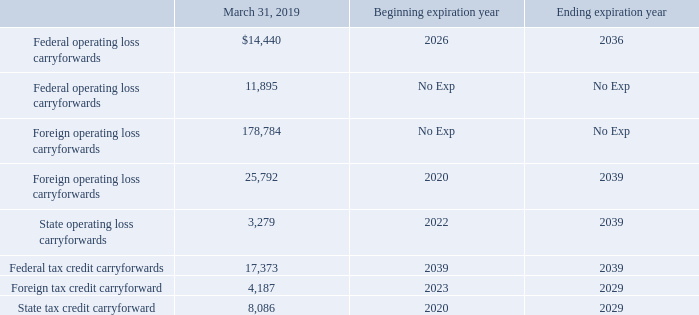The following table presents the approximate amount of federal, foreign and state operating loss carryforwards and federal tax credit carryforwards available to
reduce future taxable income, along with the respective range of years that the operating loss and tax credit carryforwards would expired if not utilized:
At March 31, 2019, certain of our U.S. and foreign subsidiaries in Brazil, France, Germany, Israel, Japan, Mexico and Korea had tax operating loss and tax credit carry
forwards totaling approximately $263,836. There is a greater likelihood of not realizing the future tax benefits of these net operating losses and other deductible
temporary differences in Brazil, Israel, China, and Korea since these losses and other deductible temporary differences must be used to offset future taxable income of
those subsidiaries, which cannot be assured, and are not available to offset taxable income of other subsidiaries located in those countries. Accordingly, we have
recorded valuation allowances related to the net deferred tax assets in these jurisdictions. Valuation allowances decreased $(12,101), and increased $317 and $6,812
during the years ended March 31, 2017, 2018, and 2019, respectively, as a result of changes in the net operating losses of the subsidiaries or as a result of changes in
foreign currency exchange rates in the countries mentioned above
The decrease in valuation allowance during the year ended March 31, 2017 was also due to the reversal of valuation allowances of $5,530 related to the future
utilization of NOLs totaling $15,878 at a Japanese subsidiary. The related tax benefits upon utilization of the Japanese NOLs expire eight years after they are generated,
and they are not subject to annual utilization limitations. The realization of tax benefits due to the utilization of these NOLs could take an extended period of time to
realize and are dependent upon the Japanese subsidiary’s continuing profitability, and some could expire prior to utilization. The increase in valuation allowance during
the year ended March 31, 2019, was due to the addition of valuation allowances of $3,124 related to the Ethertronics acquisition and $1,763 related to capital and section
1231 losses at AVX Corporation.
The decrease in valuation allowance during the year ended March 31, 2017 was also due to the reversal of valuation allowances of $5,530 related to the future utilization of NOLs totaling $15,878 at a Japanese subsidiary. The related tax benefits upon utilization of the Japanese NOLs expire eight years after they are generated, and they are not subject to annual utilization limitations. The realization of tax benefits due to the utilization of these NOLs could take an extended period of time to realize and are dependent upon the Japanese subsidiary’s continuing profitability, and some could expire prior to utilization. The increase in valuation allowance during the year ended March 31, 2019, was due to the addition of valuation allowances of $3,124 related to the Ethertronics acquisition and $1,763 related to capital and section 1231 losses at AVX Corporation.
Income taxes paid totaled $55,642, $66,354 and $75,640 during the years ended March 31, 2017, 2018 and 2019, respectively
What is the income tax paid in the year ended March 31, 2017? $55,642. What is the income tax paid in the year ended March 31, 2018? $66,354. What is the income tax paid in the year ended March 31, 2019? $75,640. What is the total income tax paid between 2017 to 2019? $55,642 + $66,354 + $75,640 
Answer: 197636. How many years is the state tax credit carryforward? 2029 - 2020 
Answer: 9. What is the total value of foreign and federal operating loss carryforwards with no expiry? 11,895 + 178,784 
Answer: 190679. 